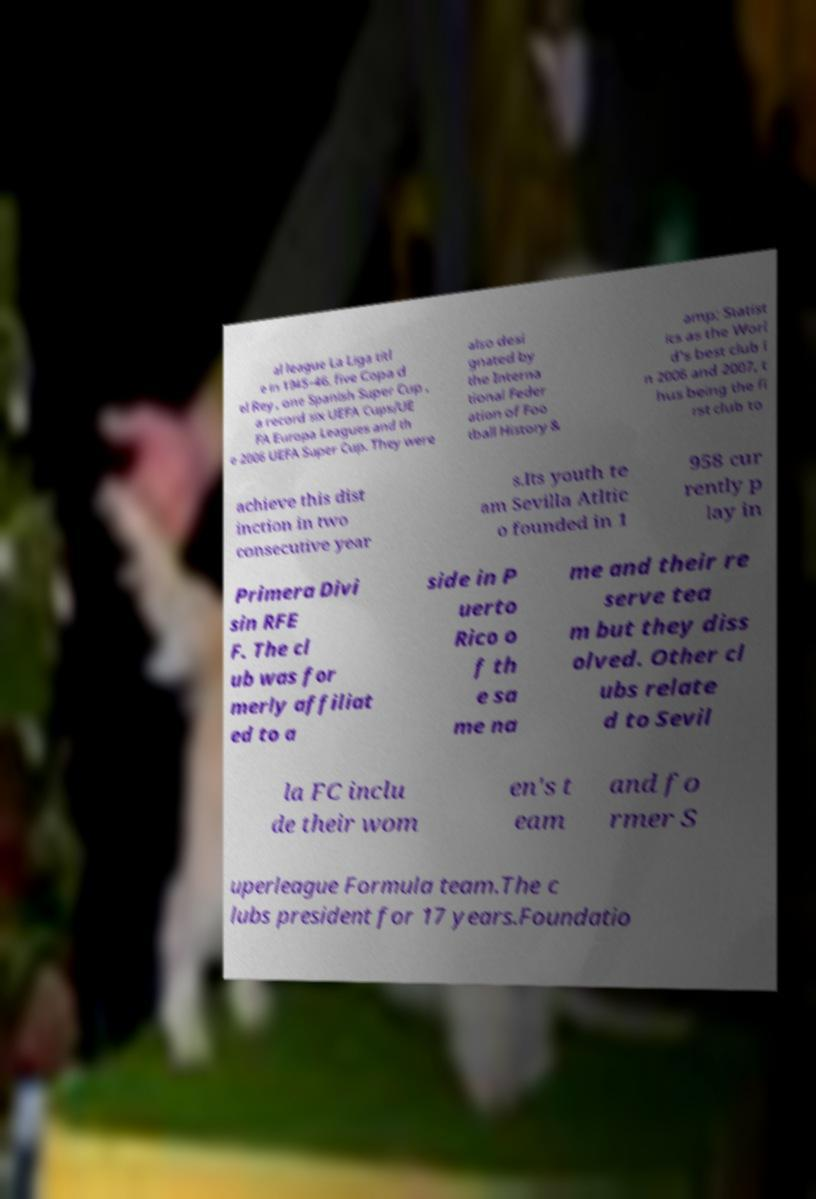Could you extract and type out the text from this image? al league La Liga titl e in 1945–46, five Copa d el Rey , one Spanish Super Cup , a record six UEFA Cups/UE FA Europa Leagues and th e 2006 UEFA Super Cup. They were also desi gnated by the Interna tional Feder ation of Foo tball History & amp; Statist ics as the Worl d's best club i n 2006 and 2007, t hus being the fi rst club to achieve this dist inction in two consecutive year s.Its youth te am Sevilla Atltic o founded in 1 958 cur rently p lay in Primera Divi sin RFE F. The cl ub was for merly affiliat ed to a side in P uerto Rico o f th e sa me na me and their re serve tea m but they diss olved. Other cl ubs relate d to Sevil la FC inclu de their wom en's t eam and fo rmer S uperleague Formula team.The c lubs president for 17 years.Foundatio 